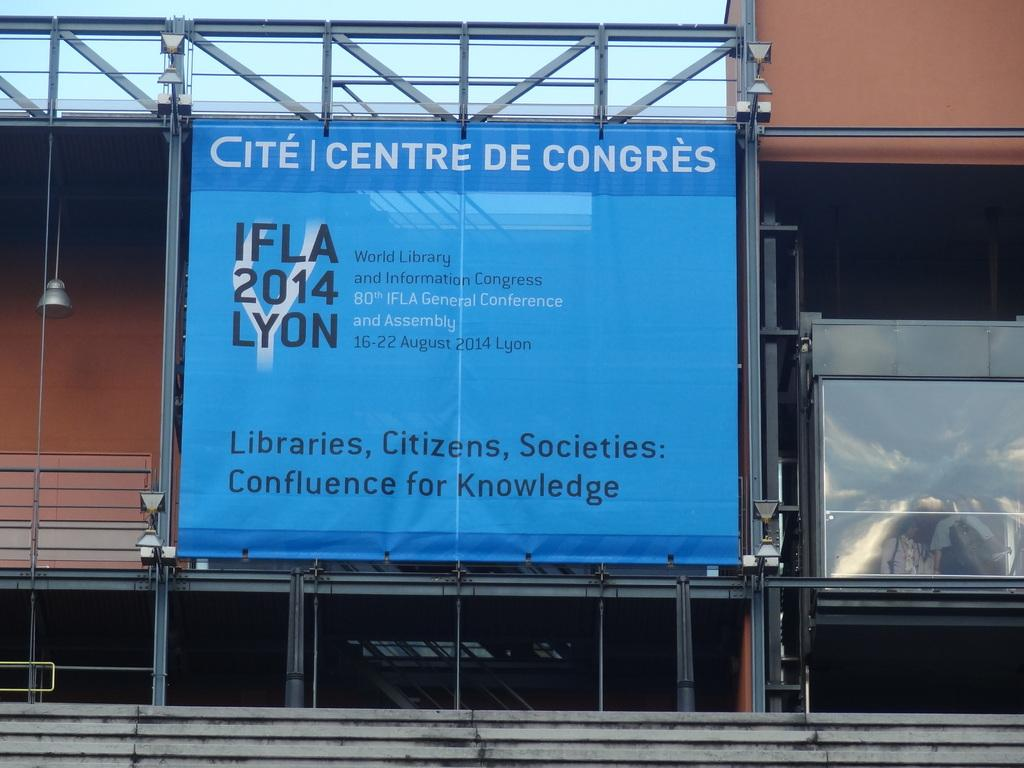<image>
Summarize the visual content of the image. A blue billboard for Cite Centre De Congres sits outside a building 